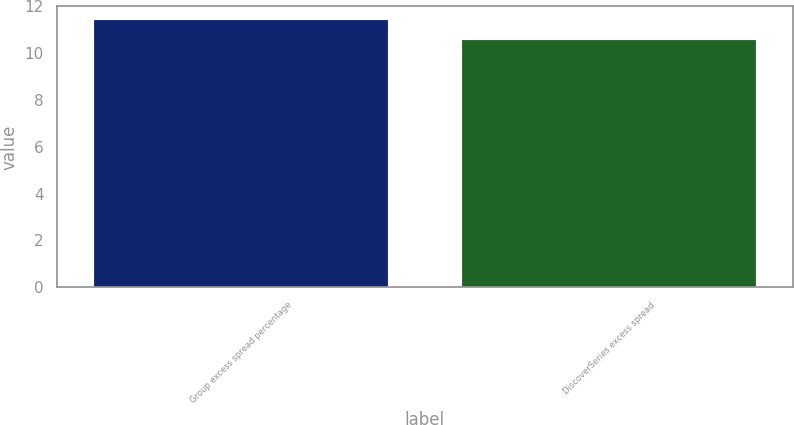Convert chart. <chart><loc_0><loc_0><loc_500><loc_500><bar_chart><fcel>Group excess spread percentage<fcel>DiscoverSeries excess spread<nl><fcel>11.43<fcel>10.57<nl></chart> 